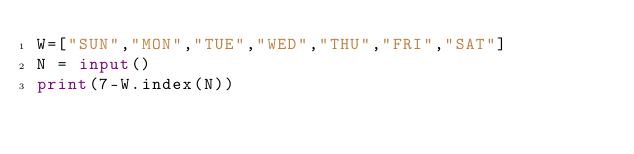Convert code to text. <code><loc_0><loc_0><loc_500><loc_500><_Python_>W=["SUN","MON","TUE","WED","THU","FRI","SAT"]
N = input()
print(7-W.index(N))</code> 